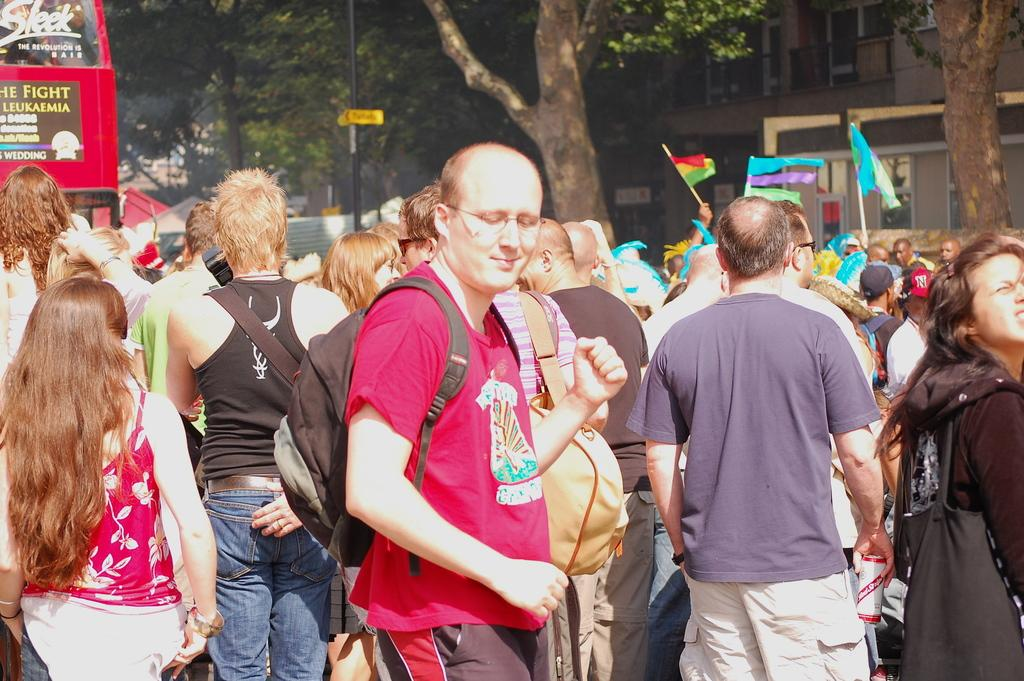What are the people in the image doing? The people in the image are standing and carrying bags. What can be seen in the background of the image? There are trees and buildings visible in the background of the image. Is there any transportation present in the image? Yes, there is a vehicle parked on the road in the image. How many birds are perched on the pot in the image? There is no pot or birds present in the image. What type of patch can be seen on the people's clothing in the image? There is no mention of patches on the people's clothing in the image. 